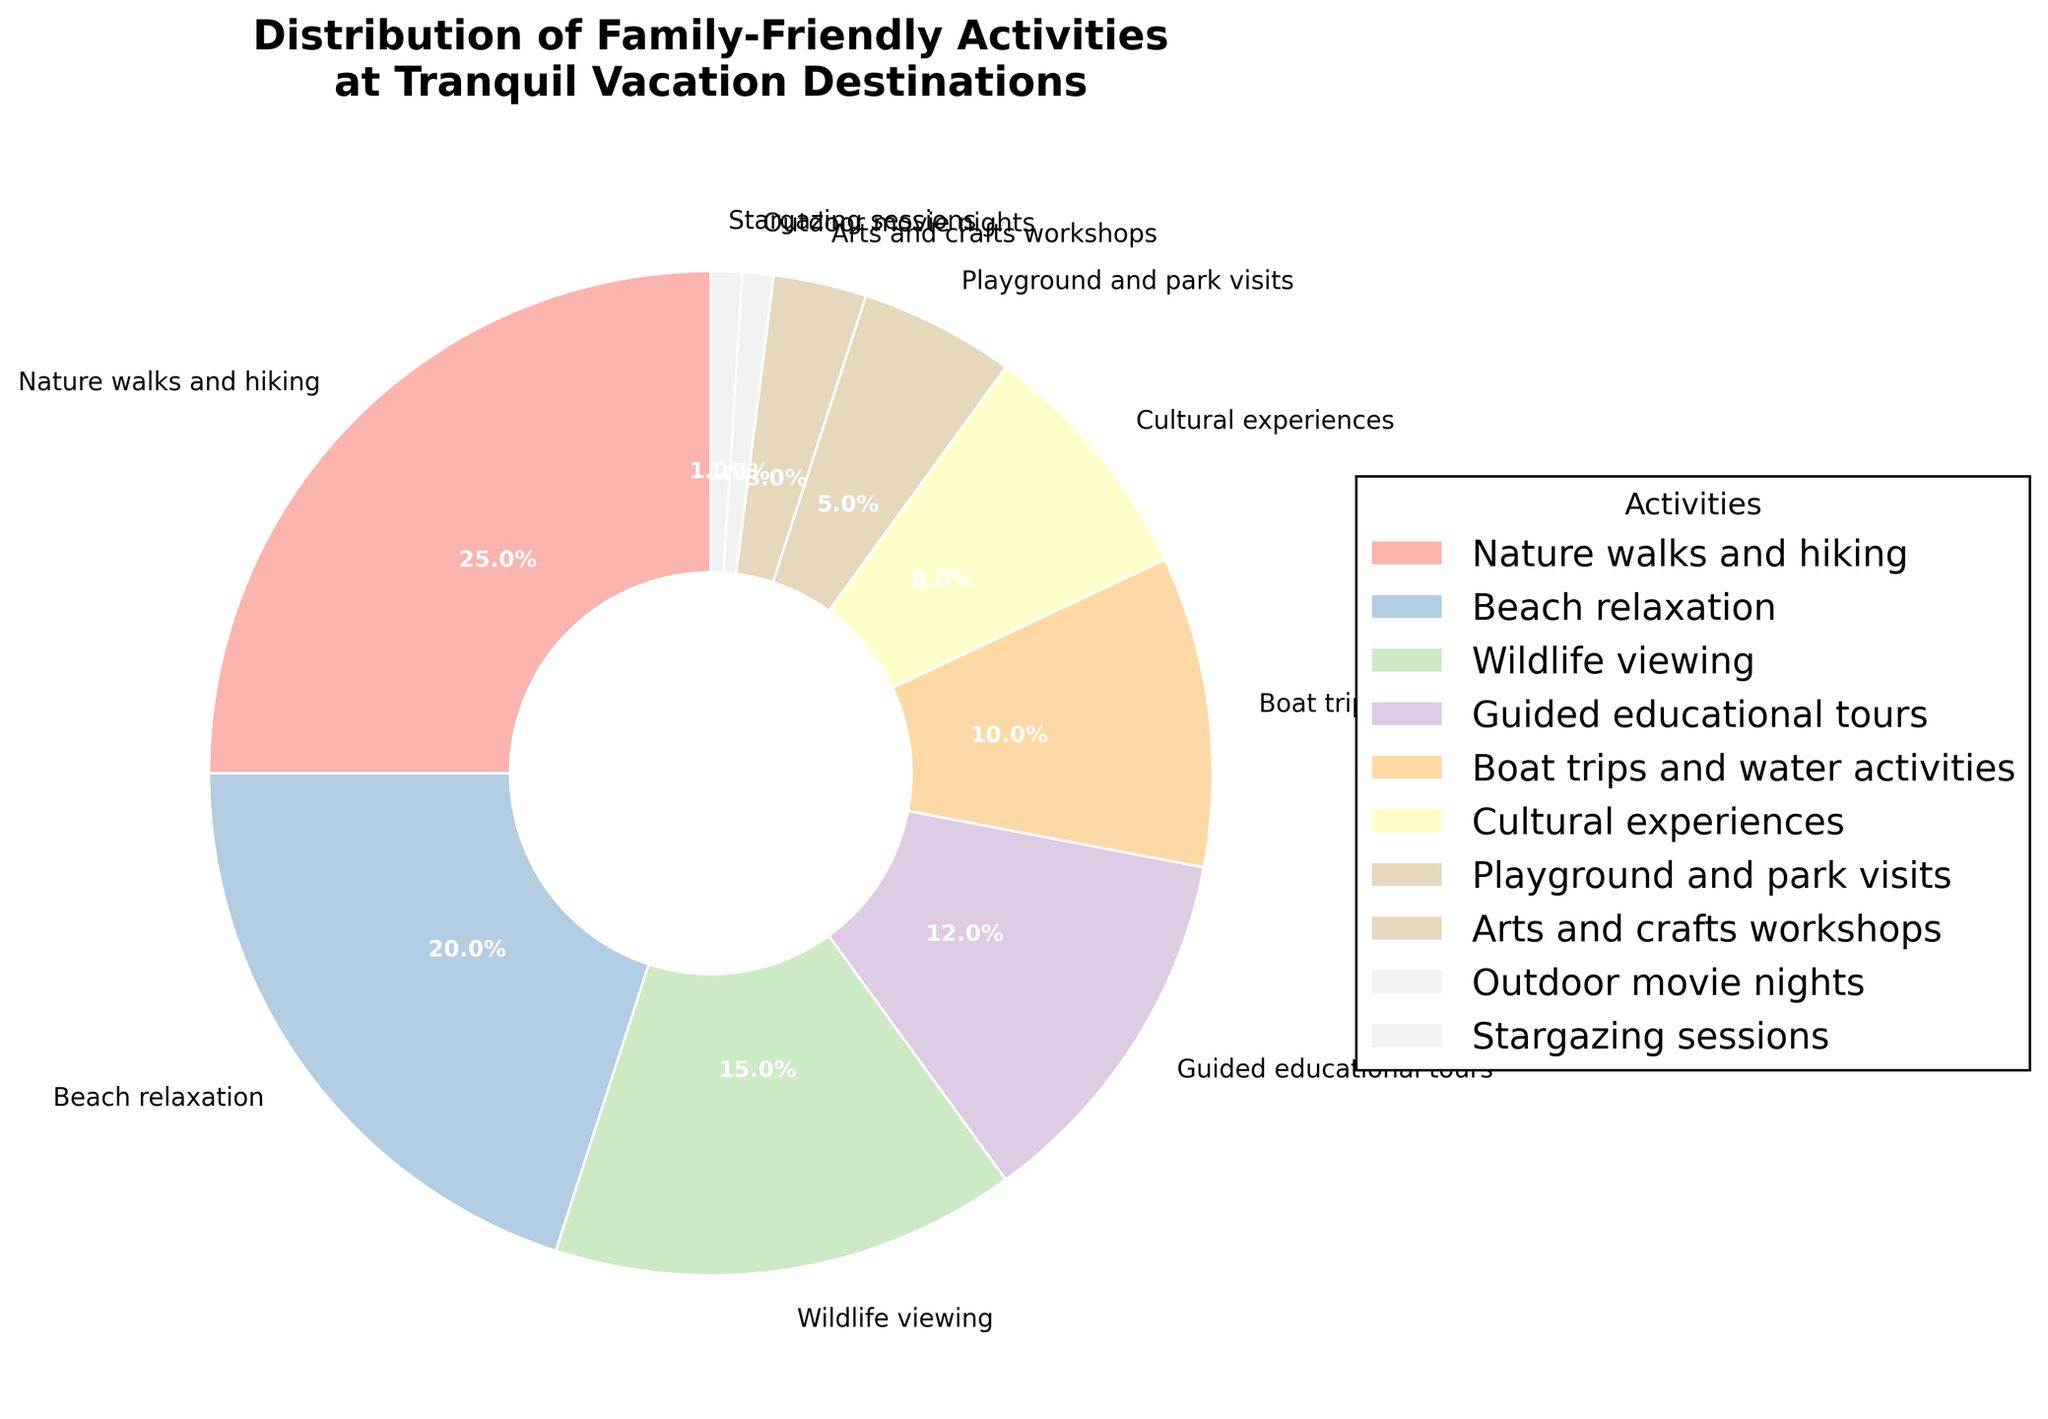Which activity takes up the largest percentage? The pie chart shows various activity segments marked with percentages. The segment with the largest percentage is "Nature walks and hiking" at 25%.
Answer: Nature walks and hiking Which activity category is the smallest? Examining the smallest segment in the pie chart, "Outdoor movie nights" and "Stargazing sessions" are both marked at 1%, making them the smallest.
Answer: Outdoor movie nights and Stargazing sessions What is the combined percentage of beach relaxation and wildlife viewing? The chart lists beach relaxation at 20% and wildlife viewing at 15%. Adding these gives 20% + 15% = 35%.
Answer: 35% How much more popular is nature walks and hiking compared to boat trips and water activities? According to the pie chart, nature walks and hiking is 25% and boat trips and water activities is 10%. The difference is 25% - 10% = 15%.
Answer: 15% What is the difference in proportion between cultural experiences and playground and park visits? Cultural experiences are 8% and playground and park visits are 5%. The difference is 8% - 5% = 3%.
Answer: 3% Which activities have less than 10% of the pie? The relevant segments marked in the pie chart below 10% are cultural experiences (8%), playground and park visits (5%), arts and crafts workshops (3%), outdoor movie nights (1%), and stargazing sessions (1%).
Answer: Cultural experiences, Playground and park visits, Arts and crafts workshops, Outdoor movie nights, Stargazing sessions What is the total percentage of outdoor activities including nature walks and hiking, wildlife viewing, and boat trips and water activities? Summing the specified categories: nature walks and hiking (25%), wildlife viewing (15%), and boat trips and water activities (10%). The total is 25% + 15% + 10% = 50%.
Answer: 50% Does any single activity account for more than a quarter of the total distribution? Examining the chart, only nature walks and hiking is exactly 25%, while no activity exceeds this percentage.
Answer: No How much more popular are guided educational tours than arts and crafts workshops? Checking the chart, guided educational tours are at 12% while arts and crafts workshops are at 3%. The difference between the two is 12% - 3% = 9%.
Answer: 9% What percentage of the pie is occupied by structured activities such as guided educational tours and arts and crafts workshops? Structured activities include guided educational tours (12%) and arts and crafts workshops (3%). Summing them, 12% + 3% = 15%.
Answer: 15% 